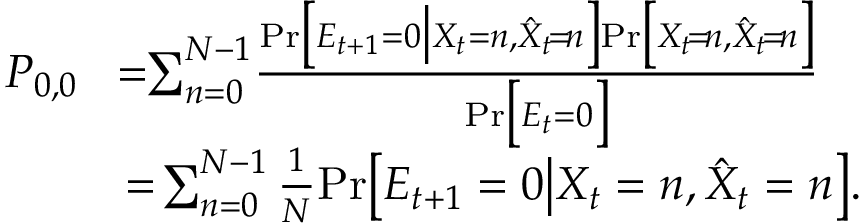<formula> <loc_0><loc_0><loc_500><loc_500>\begin{array} { r l } { P _ { 0 , 0 } } & { \, = \, \sum _ { n = 0 } ^ { N - 1 } \, \frac { P r \left [ E _ { t + 1 } = 0 \left | X _ { t } = n , \hat { X } _ { t } \, = \, n \right ] P r \left [ X _ { t } \, = \, n , \hat { X } _ { t } \, = \, n \right ] } { P r \left [ E _ { t } = 0 \right ] } } \\ & { = \, \sum _ { n = 0 } ^ { N - 1 } \frac { 1 } { N } P r \left [ E _ { t + 1 } = 0 \right | X _ { t } = n , \hat { X } _ { t } = n \right ] . } \end{array}</formula> 